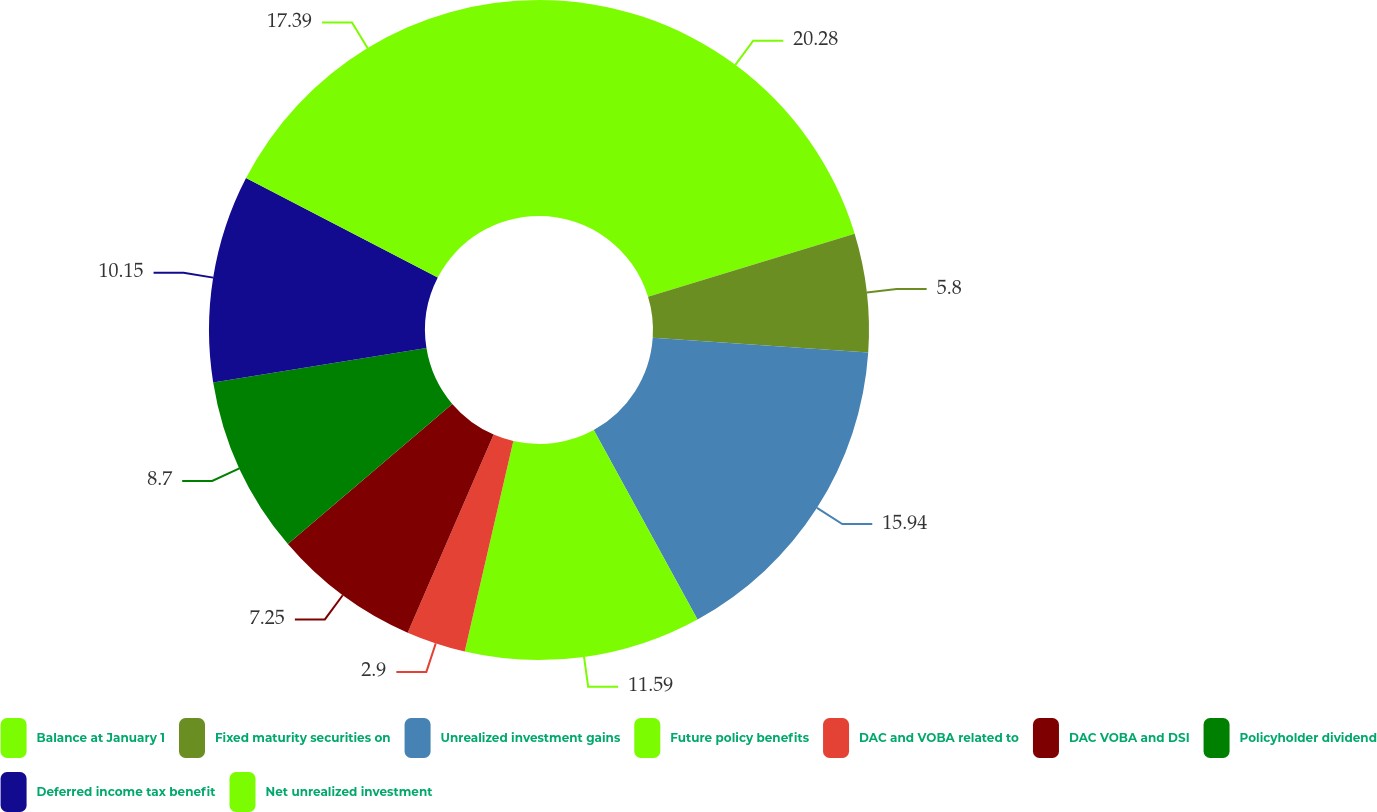<chart> <loc_0><loc_0><loc_500><loc_500><pie_chart><fcel>Balance at January 1<fcel>Fixed maturity securities on<fcel>Unrealized investment gains<fcel>Future policy benefits<fcel>DAC and VOBA related to<fcel>DAC VOBA and DSI<fcel>Policyholder dividend<fcel>Deferred income tax benefit<fcel>Net unrealized investment<nl><fcel>20.29%<fcel>5.8%<fcel>15.94%<fcel>11.59%<fcel>2.9%<fcel>7.25%<fcel>8.7%<fcel>10.15%<fcel>17.39%<nl></chart> 